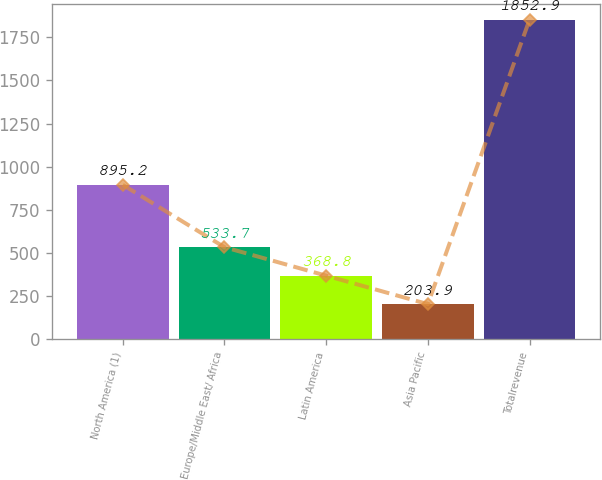Convert chart to OTSL. <chart><loc_0><loc_0><loc_500><loc_500><bar_chart><fcel>North America (1)<fcel>Europe/Middle East/ Africa<fcel>Latin America<fcel>Asia Pacific<fcel>Totalrevenue<nl><fcel>895.2<fcel>533.7<fcel>368.8<fcel>203.9<fcel>1852.9<nl></chart> 